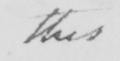Please provide the text content of this handwritten line. this 